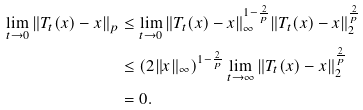Convert formula to latex. <formula><loc_0><loc_0><loc_500><loc_500>\lim _ { t \to 0 } \| T _ { t } ( x ) - x \| _ { p } & \leq \lim _ { t \to 0 } \| T _ { t } ( x ) - x \| _ { \infty } ^ { 1 - \frac { 2 } { p } } \| T _ { t } ( x ) - x \| _ { 2 } ^ { \frac { 2 } { p } } \\ & \leq ( 2 \| x \| _ { \infty } ) ^ { 1 - \frac { 2 } { p } } \lim _ { t \to \infty } \| T _ { t } ( x ) - x \| _ { 2 } ^ { \frac { 2 } { p } } \\ & = 0 .</formula> 